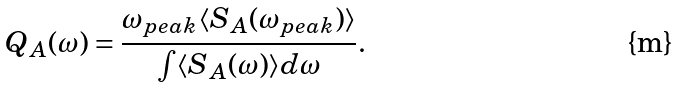<formula> <loc_0><loc_0><loc_500><loc_500>Q _ { A } ( \omega ) = \frac { \omega _ { p e a k } \langle S _ { A } ( \omega _ { p e a k } ) \rangle } { \int \langle S _ { A } ( \omega ) \rangle d \omega } .</formula> 